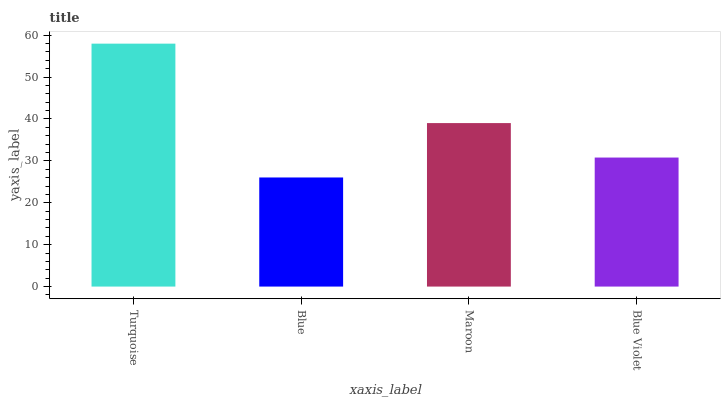Is Maroon the minimum?
Answer yes or no. No. Is Maroon the maximum?
Answer yes or no. No. Is Maroon greater than Blue?
Answer yes or no. Yes. Is Blue less than Maroon?
Answer yes or no. Yes. Is Blue greater than Maroon?
Answer yes or no. No. Is Maroon less than Blue?
Answer yes or no. No. Is Maroon the high median?
Answer yes or no. Yes. Is Blue Violet the low median?
Answer yes or no. Yes. Is Blue Violet the high median?
Answer yes or no. No. Is Maroon the low median?
Answer yes or no. No. 